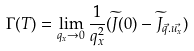<formula> <loc_0><loc_0><loc_500><loc_500>\Gamma ( T ) = \lim _ { q _ { x } \rightarrow 0 } \frac { 1 } { q _ { x } ^ { 2 } } ( \widetilde { J } ( 0 ) - \widetilde { J } _ { \vec { q } . \vec { u _ { x } } } )</formula> 